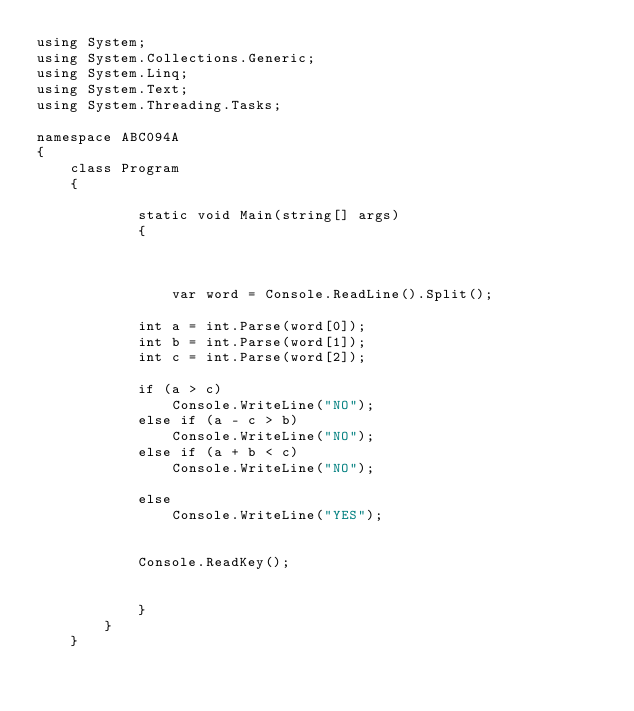<code> <loc_0><loc_0><loc_500><loc_500><_C#_>using System;
using System.Collections.Generic;
using System.Linq;
using System.Text;
using System.Threading.Tasks;

namespace ABC094A
{
    class Program
    {
        
            static void Main(string[] args)
            {



                var word = Console.ReadLine().Split();

            int a = int.Parse(word[0]);
            int b = int.Parse(word[1]);
            int c = int.Parse(word[2]);

            if (a > c)
                Console.WriteLine("NO");
            else if (a - c > b)
                Console.WriteLine("NO");
            else if (a + b < c)
                Console.WriteLine("NO");

            else
                Console.WriteLine("YES");


            Console.ReadKey();


            }
        }
    }</code> 